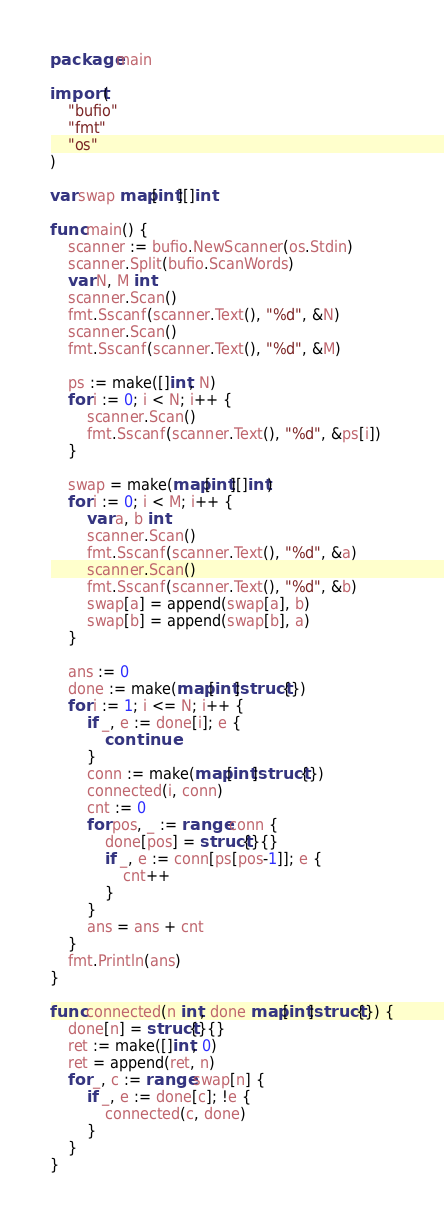<code> <loc_0><loc_0><loc_500><loc_500><_Go_>package main

import (
	"bufio"
	"fmt"
	"os"
)

var swap map[int][]int

func main() {
	scanner := bufio.NewScanner(os.Stdin)
	scanner.Split(bufio.ScanWords)
	var N, M int
	scanner.Scan()
	fmt.Sscanf(scanner.Text(), "%d", &N)
	scanner.Scan()
	fmt.Sscanf(scanner.Text(), "%d", &M)

	ps := make([]int, N)
	for i := 0; i < N; i++ {
		scanner.Scan()
		fmt.Sscanf(scanner.Text(), "%d", &ps[i])
	}

	swap = make(map[int][]int)
	for i := 0; i < M; i++ {
		var a, b int
		scanner.Scan()
		fmt.Sscanf(scanner.Text(), "%d", &a)
		scanner.Scan()
		fmt.Sscanf(scanner.Text(), "%d", &b)
		swap[a] = append(swap[a], b)
		swap[b] = append(swap[b], a)
	}

	ans := 0
	done := make(map[int]struct{})
	for i := 1; i <= N; i++ {
		if _, e := done[i]; e {
			continue
		}
		conn := make(map[int]struct{})
		connected(i, conn)
		cnt := 0
		for pos, _ := range conn {
			done[pos] = struct{}{}
			if _, e := conn[ps[pos-1]]; e {
				cnt++
			}
		}
		ans = ans + cnt
	}
	fmt.Println(ans)
}

func connected(n int, done map[int]struct{}) {
	done[n] = struct{}{}
	ret := make([]int, 0)
	ret = append(ret, n)
	for _, c := range swap[n] {
		if _, e := done[c]; !e {
			connected(c, done)
		}
	}
}
</code> 